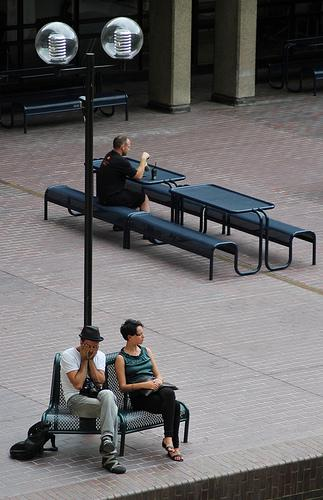Question: how many people are there?
Choices:
A. 4.
B. 3.
C. 6.
D. 8.
Answer with the letter. Answer: B Question: where is the man in the black shirt sitting?
Choices:
A. On a bench.
B. On his bed.
C. At the picnic table.
D. On a horse.
Answer with the letter. Answer: C Question: who is wearing a hat?
Choices:
A. The boy.
B. Man sitting on bench.
C. The soldier.
D. The camper.
Answer with the letter. Answer: B Question: how many women are there?
Choices:
A. 3.
B. 4.
C. 8.
D. 1.
Answer with the letter. Answer: D 